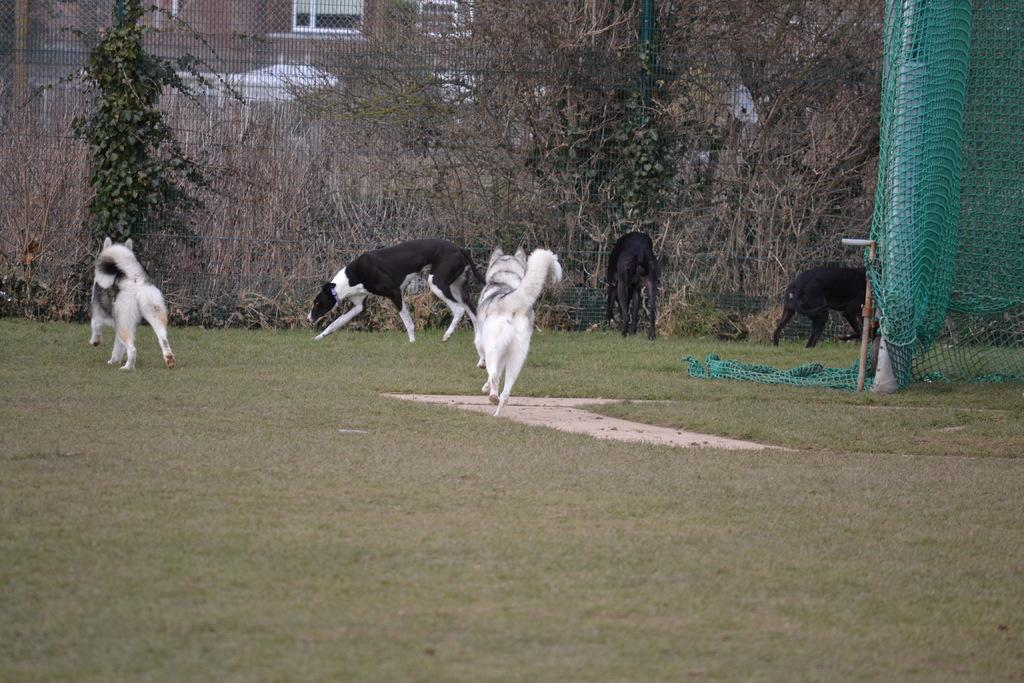What animals can be seen in the image? There are dogs in the image. What can be seen in the distance behind the dogs? There are trees and a building in the background of the image. What is on the right side of the image? There is a green net on the right side of the image. What type of terrain is visible in the image? There is grass on the ground in the image. What type of calculator is being used by the dogs in the image? There is no calculator present in the image; it features dogs, trees, a building, a green net, and grass on the ground. 